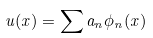Convert formula to latex. <formula><loc_0><loc_0><loc_500><loc_500>u ( x ) = \sum a _ { n } \phi _ { n } ( x )</formula> 